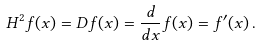<formula> <loc_0><loc_0><loc_500><loc_500>H ^ { 2 } f ( x ) = D f ( x ) = { \frac { d } { d x } } f ( x ) = f ^ { \prime } ( x ) \, .</formula> 